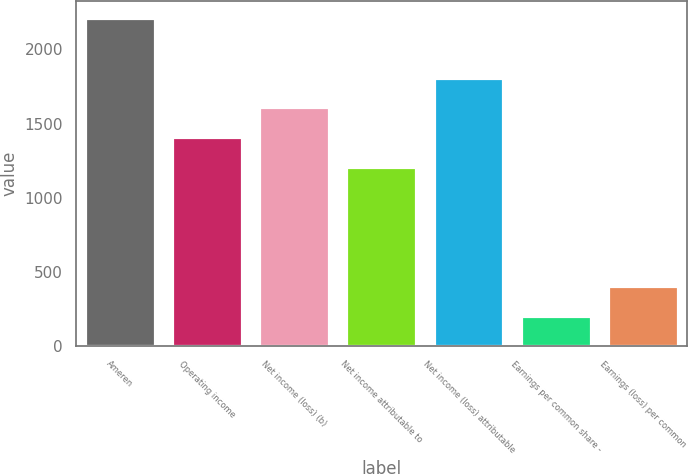<chart> <loc_0><loc_0><loc_500><loc_500><bar_chart><fcel>Ameren<fcel>Operating income<fcel>Net income (loss) (b)<fcel>Net income attributable to<fcel>Net income (loss) attributable<fcel>Earnings per common share -<fcel>Earnings (loss) per common<nl><fcel>2213.14<fcel>1408.42<fcel>1609.6<fcel>1207.24<fcel>1810.78<fcel>201.34<fcel>402.52<nl></chart> 